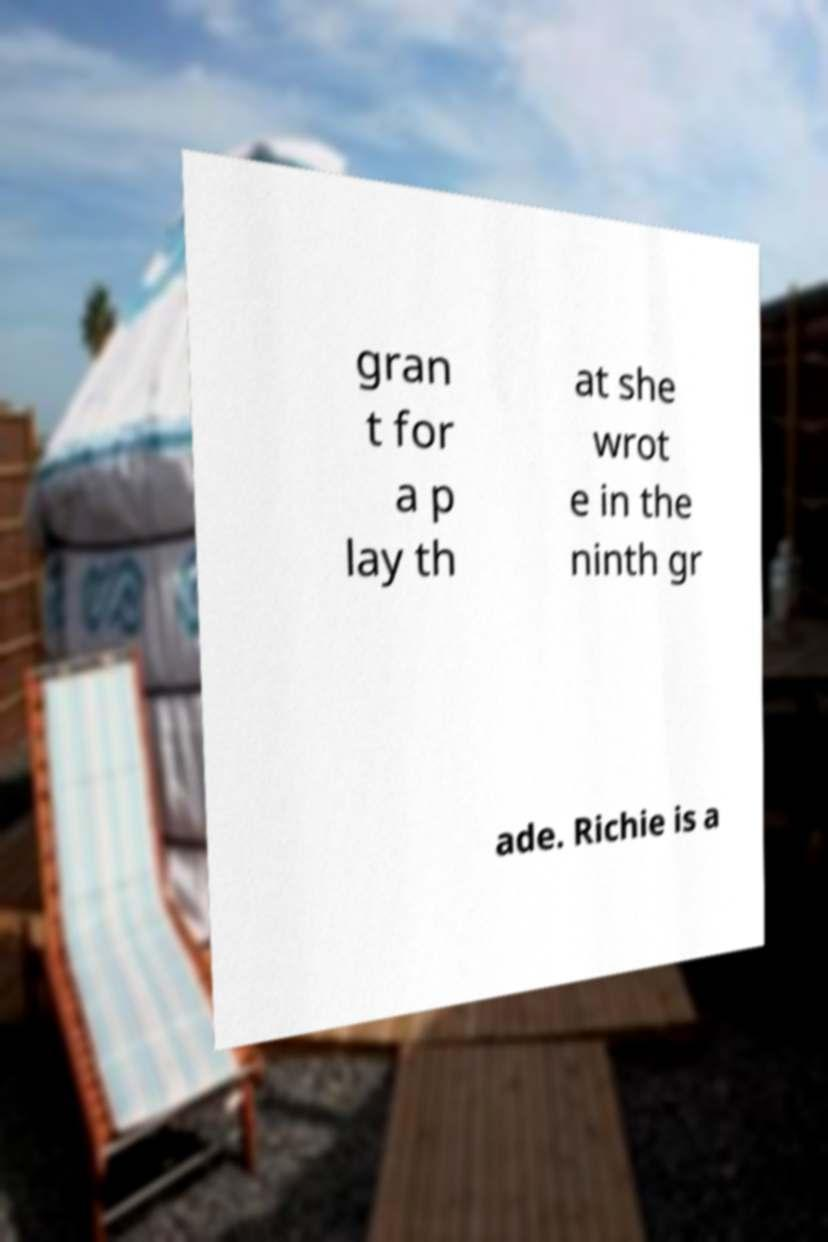What messages or text are displayed in this image? I need them in a readable, typed format. gran t for a p lay th at she wrot e in the ninth gr ade. Richie is a 